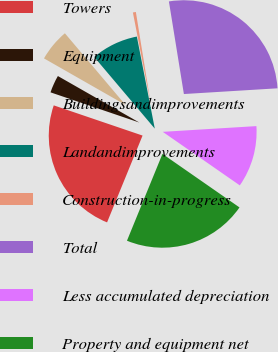Convert chart to OTSL. <chart><loc_0><loc_0><loc_500><loc_500><pie_chart><fcel>Towers<fcel>Equipment<fcel>Buildingsandimprovements<fcel>Landandimprovements<fcel>Construction-in-progress<fcel>Total<fcel>Less accumulated depreciation<fcel>Property and equipment net<nl><fcel>24.04%<fcel>3.04%<fcel>5.57%<fcel>8.11%<fcel>0.51%<fcel>26.58%<fcel>10.64%<fcel>21.51%<nl></chart> 